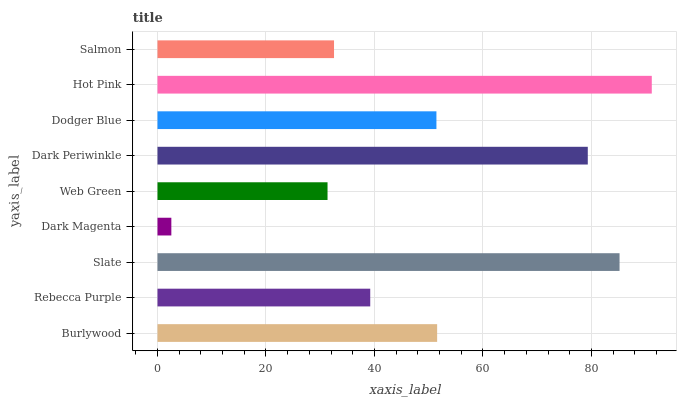Is Dark Magenta the minimum?
Answer yes or no. Yes. Is Hot Pink the maximum?
Answer yes or no. Yes. Is Rebecca Purple the minimum?
Answer yes or no. No. Is Rebecca Purple the maximum?
Answer yes or no. No. Is Burlywood greater than Rebecca Purple?
Answer yes or no. Yes. Is Rebecca Purple less than Burlywood?
Answer yes or no. Yes. Is Rebecca Purple greater than Burlywood?
Answer yes or no. No. Is Burlywood less than Rebecca Purple?
Answer yes or no. No. Is Dodger Blue the high median?
Answer yes or no. Yes. Is Dodger Blue the low median?
Answer yes or no. Yes. Is Salmon the high median?
Answer yes or no. No. Is Rebecca Purple the low median?
Answer yes or no. No. 